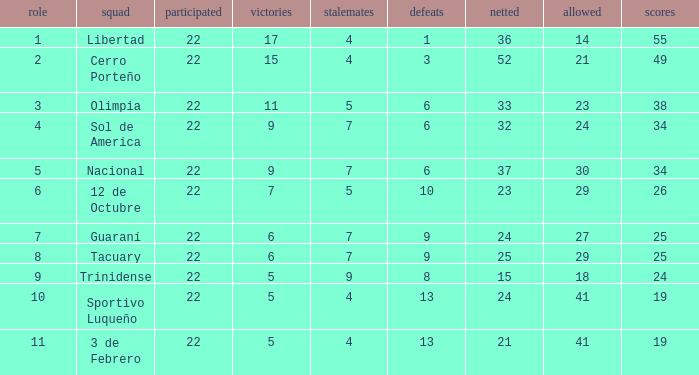What was the number of losses when the scored value was 25? 9.0. 